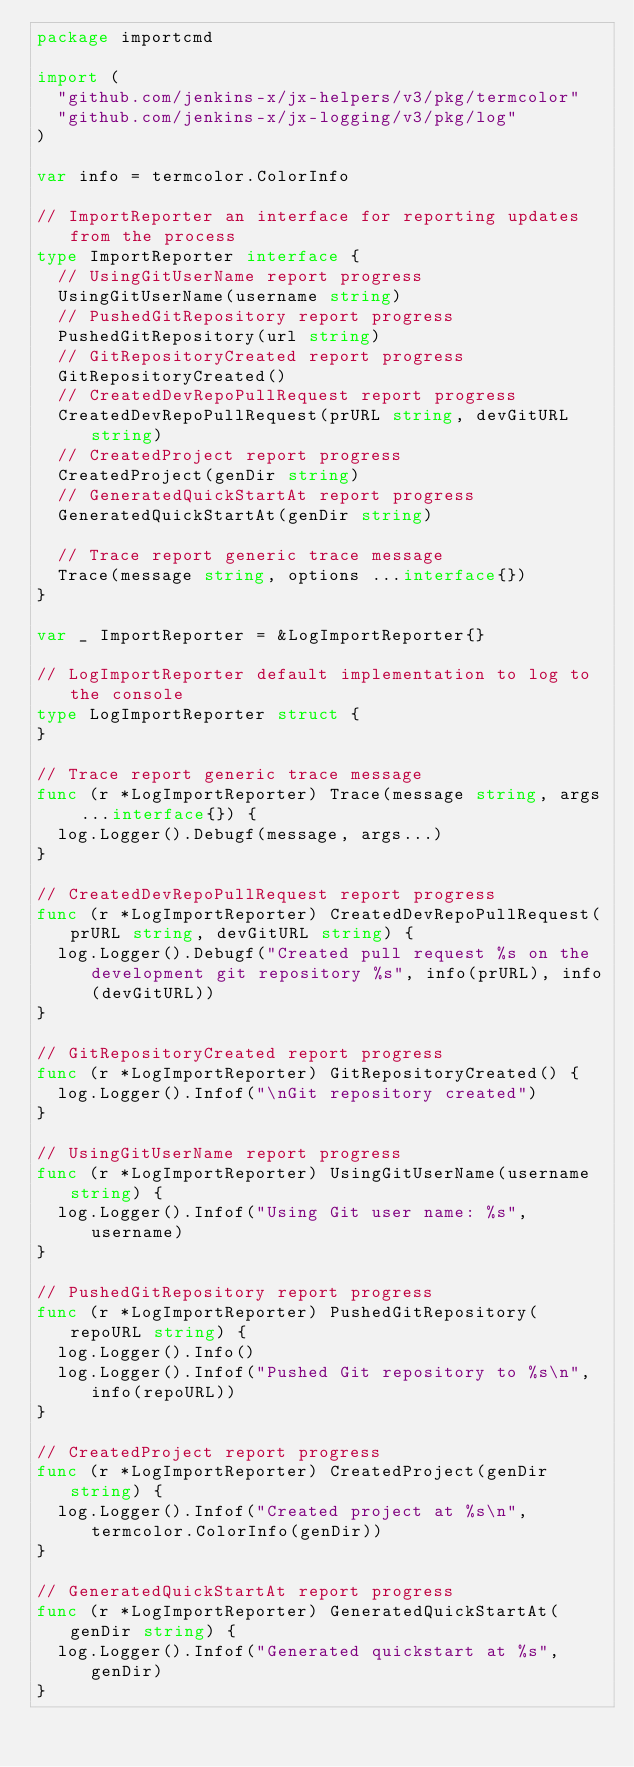<code> <loc_0><loc_0><loc_500><loc_500><_Go_>package importcmd

import (
	"github.com/jenkins-x/jx-helpers/v3/pkg/termcolor"
	"github.com/jenkins-x/jx-logging/v3/pkg/log"
)

var info = termcolor.ColorInfo

// ImportReporter an interface for reporting updates from the process
type ImportReporter interface {
	// UsingGitUserName report progress
	UsingGitUserName(username string)
	// PushedGitRepository report progress
	PushedGitRepository(url string)
	// GitRepositoryCreated report progress
	GitRepositoryCreated()
	// CreatedDevRepoPullRequest report progress
	CreatedDevRepoPullRequest(prURL string, devGitURL string)
	// CreatedProject report progress
	CreatedProject(genDir string)
	// GeneratedQuickStartAt report progress
	GeneratedQuickStartAt(genDir string)

	// Trace report generic trace message
	Trace(message string, options ...interface{})
}

var _ ImportReporter = &LogImportReporter{}

// LogImportReporter default implementation to log to the console
type LogImportReporter struct {
}

// Trace report generic trace message
func (r *LogImportReporter) Trace(message string, args ...interface{}) {
	log.Logger().Debugf(message, args...)
}

// CreatedDevRepoPullRequest report progress
func (r *LogImportReporter) CreatedDevRepoPullRequest(prURL string, devGitURL string) {
	log.Logger().Debugf("Created pull request %s on the development git repository %s", info(prURL), info(devGitURL))
}

// GitRepositoryCreated report progress
func (r *LogImportReporter) GitRepositoryCreated() {
	log.Logger().Infof("\nGit repository created")
}

// UsingGitUserName report progress
func (r *LogImportReporter) UsingGitUserName(username string) {
	log.Logger().Infof("Using Git user name: %s", username)
}

// PushedGitRepository report progress
func (r *LogImportReporter) PushedGitRepository(repoURL string) {
	log.Logger().Info()
	log.Logger().Infof("Pushed Git repository to %s\n", info(repoURL))
}

// CreatedProject report progress
func (r *LogImportReporter) CreatedProject(genDir string) {
	log.Logger().Infof("Created project at %s\n", termcolor.ColorInfo(genDir))
}

// GeneratedQuickStartAt report progress
func (r *LogImportReporter) GeneratedQuickStartAt(genDir string) {
	log.Logger().Infof("Generated quickstart at %s", genDir)
}
</code> 